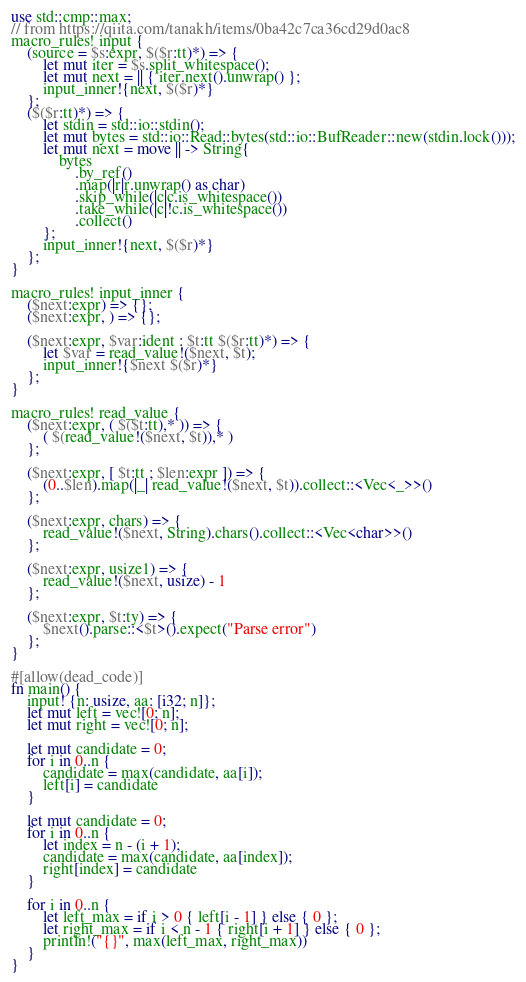<code> <loc_0><loc_0><loc_500><loc_500><_Rust_>use std::cmp::max;
// from https://qiita.com/tanakh/items/0ba42c7ca36cd29d0ac8
macro_rules! input {
    (source = $s:expr, $($r:tt)*) => {
        let mut iter = $s.split_whitespace();
        let mut next = || { iter.next().unwrap() };
        input_inner!{next, $($r)*}
    };
    ($($r:tt)*) => {
        let stdin = std::io::stdin();
        let mut bytes = std::io::Read::bytes(std::io::BufReader::new(stdin.lock()));
        let mut next = move || -> String{
            bytes
                .by_ref()
                .map(|r|r.unwrap() as char)
                .skip_while(|c|c.is_whitespace())
                .take_while(|c|!c.is_whitespace())
                .collect()
        };
        input_inner!{next, $($r)*}
    };
}

macro_rules! input_inner {
    ($next:expr) => {};
    ($next:expr, ) => {};

    ($next:expr, $var:ident : $t:tt $($r:tt)*) => {
        let $var = read_value!($next, $t);
        input_inner!{$next $($r)*}
    };
}

macro_rules! read_value {
    ($next:expr, ( $($t:tt),* )) => {
        ( $(read_value!($next, $t)),* )
    };

    ($next:expr, [ $t:tt ; $len:expr ]) => {
        (0..$len).map(|_| read_value!($next, $t)).collect::<Vec<_>>()
    };

    ($next:expr, chars) => {
        read_value!($next, String).chars().collect::<Vec<char>>()
    };

    ($next:expr, usize1) => {
        read_value!($next, usize) - 1
    };

    ($next:expr, $t:ty) => {
        $next().parse::<$t>().expect("Parse error")
    };
}

#[allow(dead_code)]
fn main() {
    input! {n: usize, aa: [i32; n]};
    let mut left = vec![0; n];
    let mut right = vec![0; n];

    let mut candidate = 0;
    for i in 0..n {
        candidate = max(candidate, aa[i]);
        left[i] = candidate
    }

    let mut candidate = 0;
    for i in 0..n {
        let index = n - (i + 1);
        candidate = max(candidate, aa[index]);
        right[index] = candidate
    }

    for i in 0..n {
        let left_max = if i > 0 { left[i - 1] } else { 0 };
        let right_max = if i < n - 1 { right[i + 1] } else { 0 };
        println!("{}", max(left_max, right_max))
    }
}
</code> 